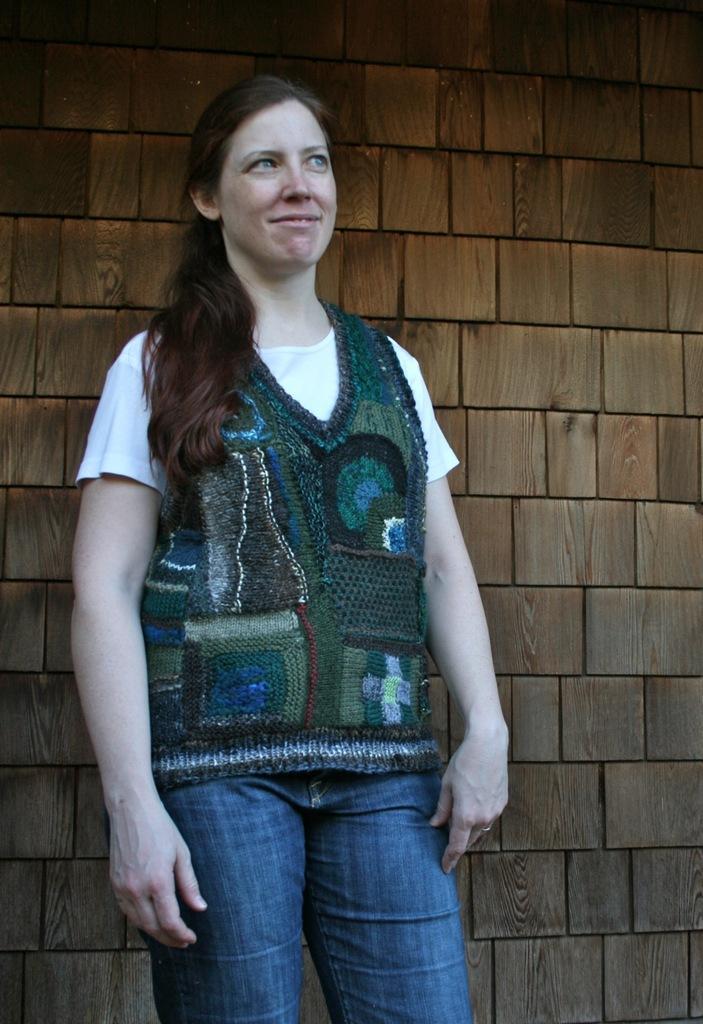Could you give a brief overview of what you see in this image? In this image, we can see a woman is standing and smiling. Background we can see a wooden brick wall. 